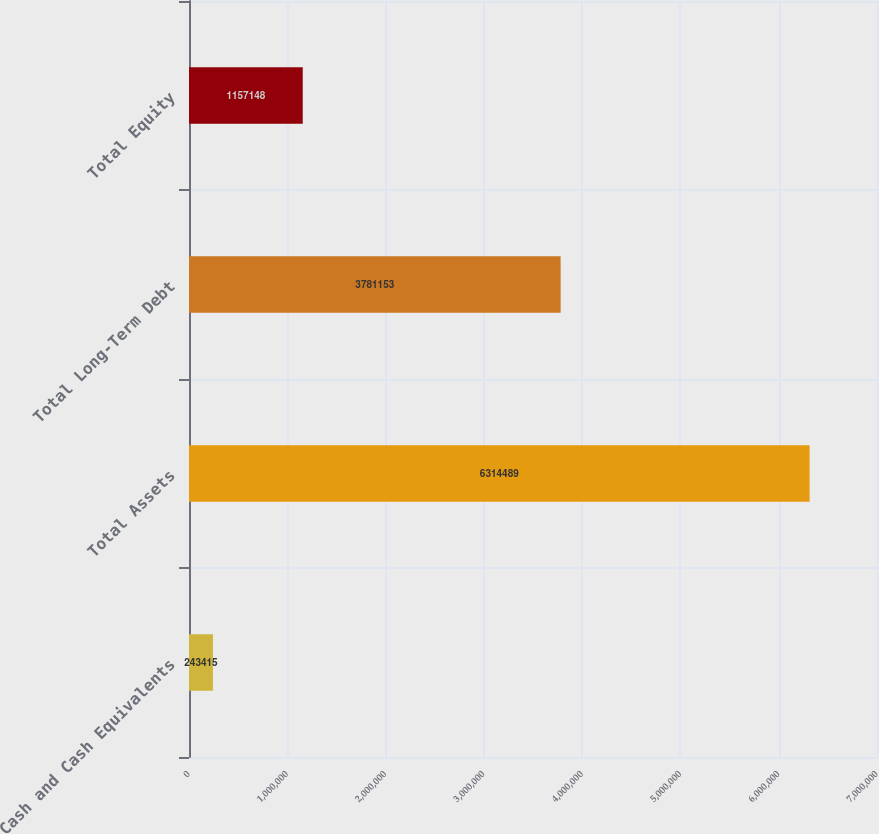Convert chart. <chart><loc_0><loc_0><loc_500><loc_500><bar_chart><fcel>Cash and Cash Equivalents<fcel>Total Assets<fcel>Total Long-Term Debt<fcel>Total Equity<nl><fcel>243415<fcel>6.31449e+06<fcel>3.78115e+06<fcel>1.15715e+06<nl></chart> 